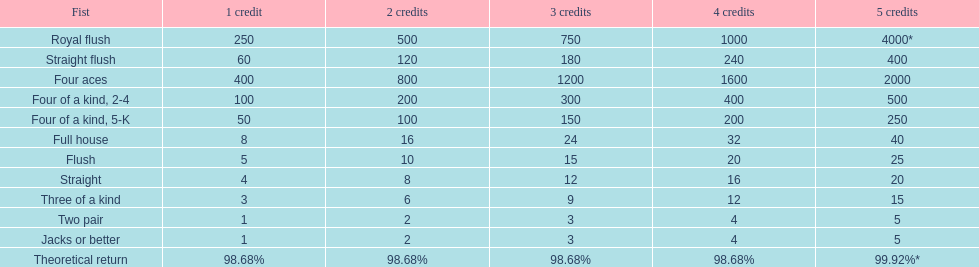Is four 5s worth more or less than four 2s? Less. 